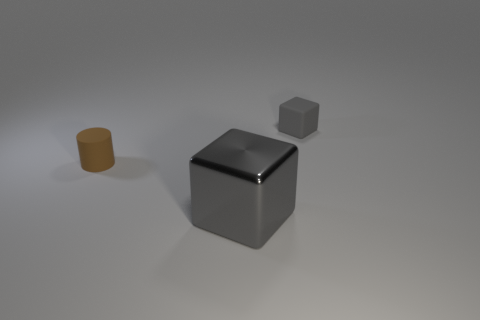How many things are right of the tiny brown rubber cylinder and left of the rubber block?
Provide a succinct answer. 1. What number of yellow objects are either small rubber blocks or metallic objects?
Your answer should be very brief. 0. There is a small cube to the right of the big shiny object; does it have the same color as the block in front of the tiny matte cube?
Offer a very short reply. Yes. What is the color of the small object that is on the left side of the gray thing in front of the brown rubber cylinder that is on the left side of the metal thing?
Ensure brevity in your answer.  Brown. There is a block left of the gray matte block; are there any tiny matte cylinders that are left of it?
Ensure brevity in your answer.  Yes. Does the small rubber thing that is behind the small brown thing have the same shape as the brown thing?
Your answer should be very brief. No. Is there anything else that is the same shape as the brown matte thing?
Make the answer very short. No. How many blocks are brown matte things or rubber objects?
Keep it short and to the point. 1. What number of small cylinders are there?
Give a very brief answer. 1. There is a gray object that is in front of the tiny matte thing in front of the small rubber cube; what is its size?
Offer a very short reply. Large. 